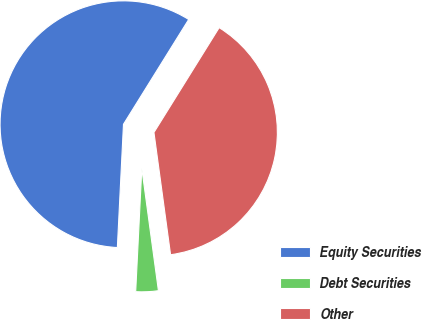<chart> <loc_0><loc_0><loc_500><loc_500><pie_chart><fcel>Equity Securities<fcel>Debt Securities<fcel>Other<nl><fcel>58.07%<fcel>2.94%<fcel>38.99%<nl></chart> 